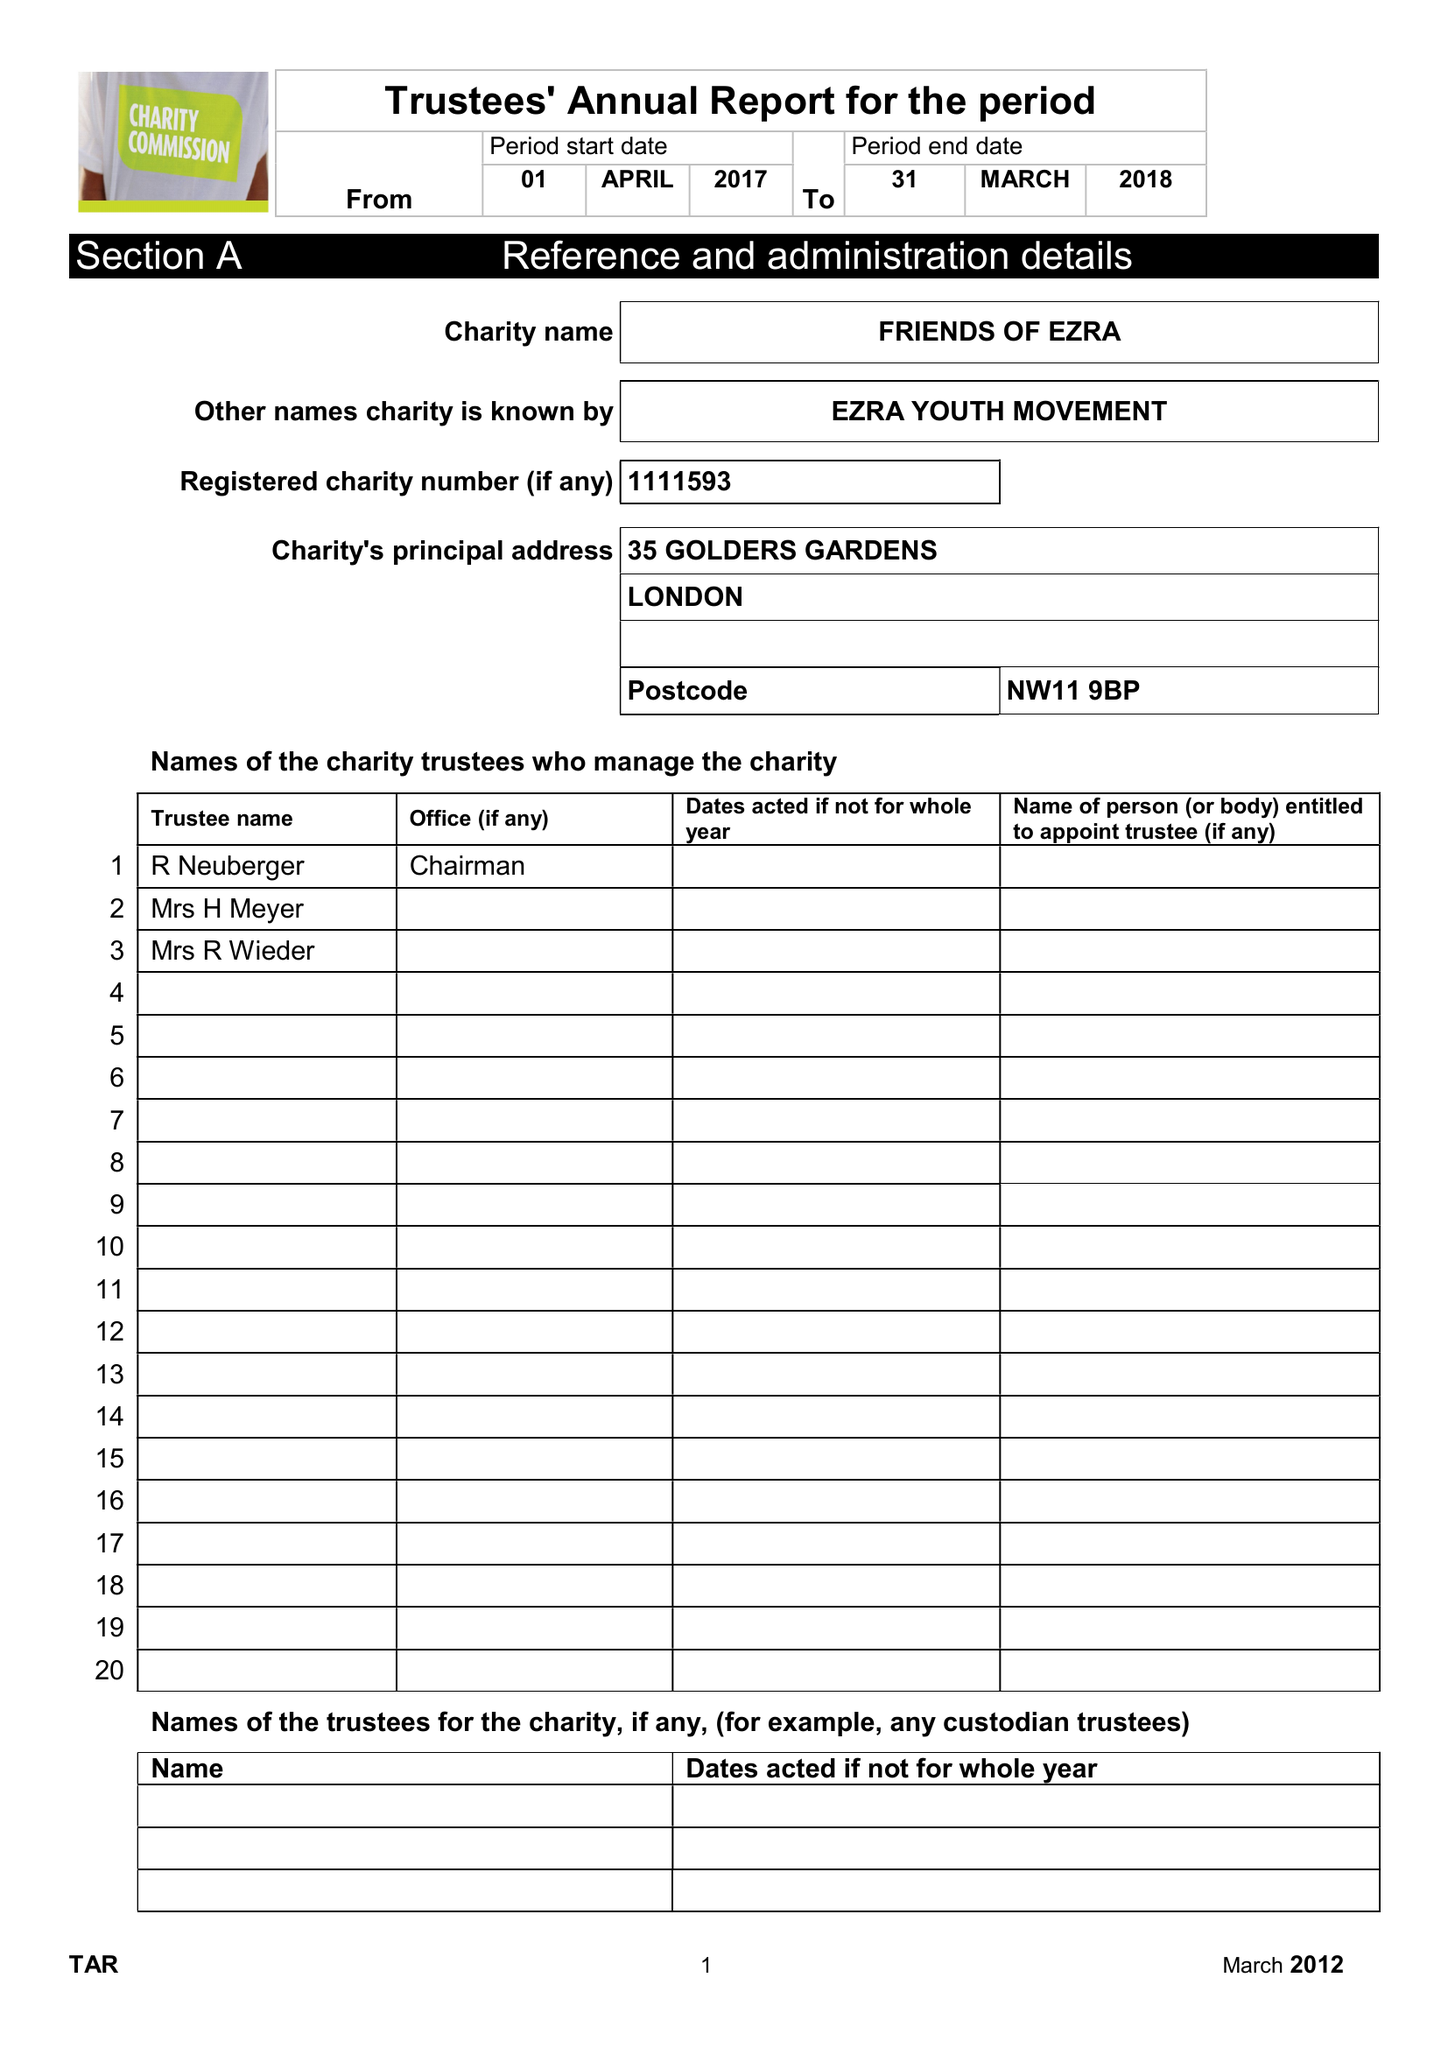What is the value for the spending_annually_in_british_pounds?
Answer the question using a single word or phrase. 368182.00 